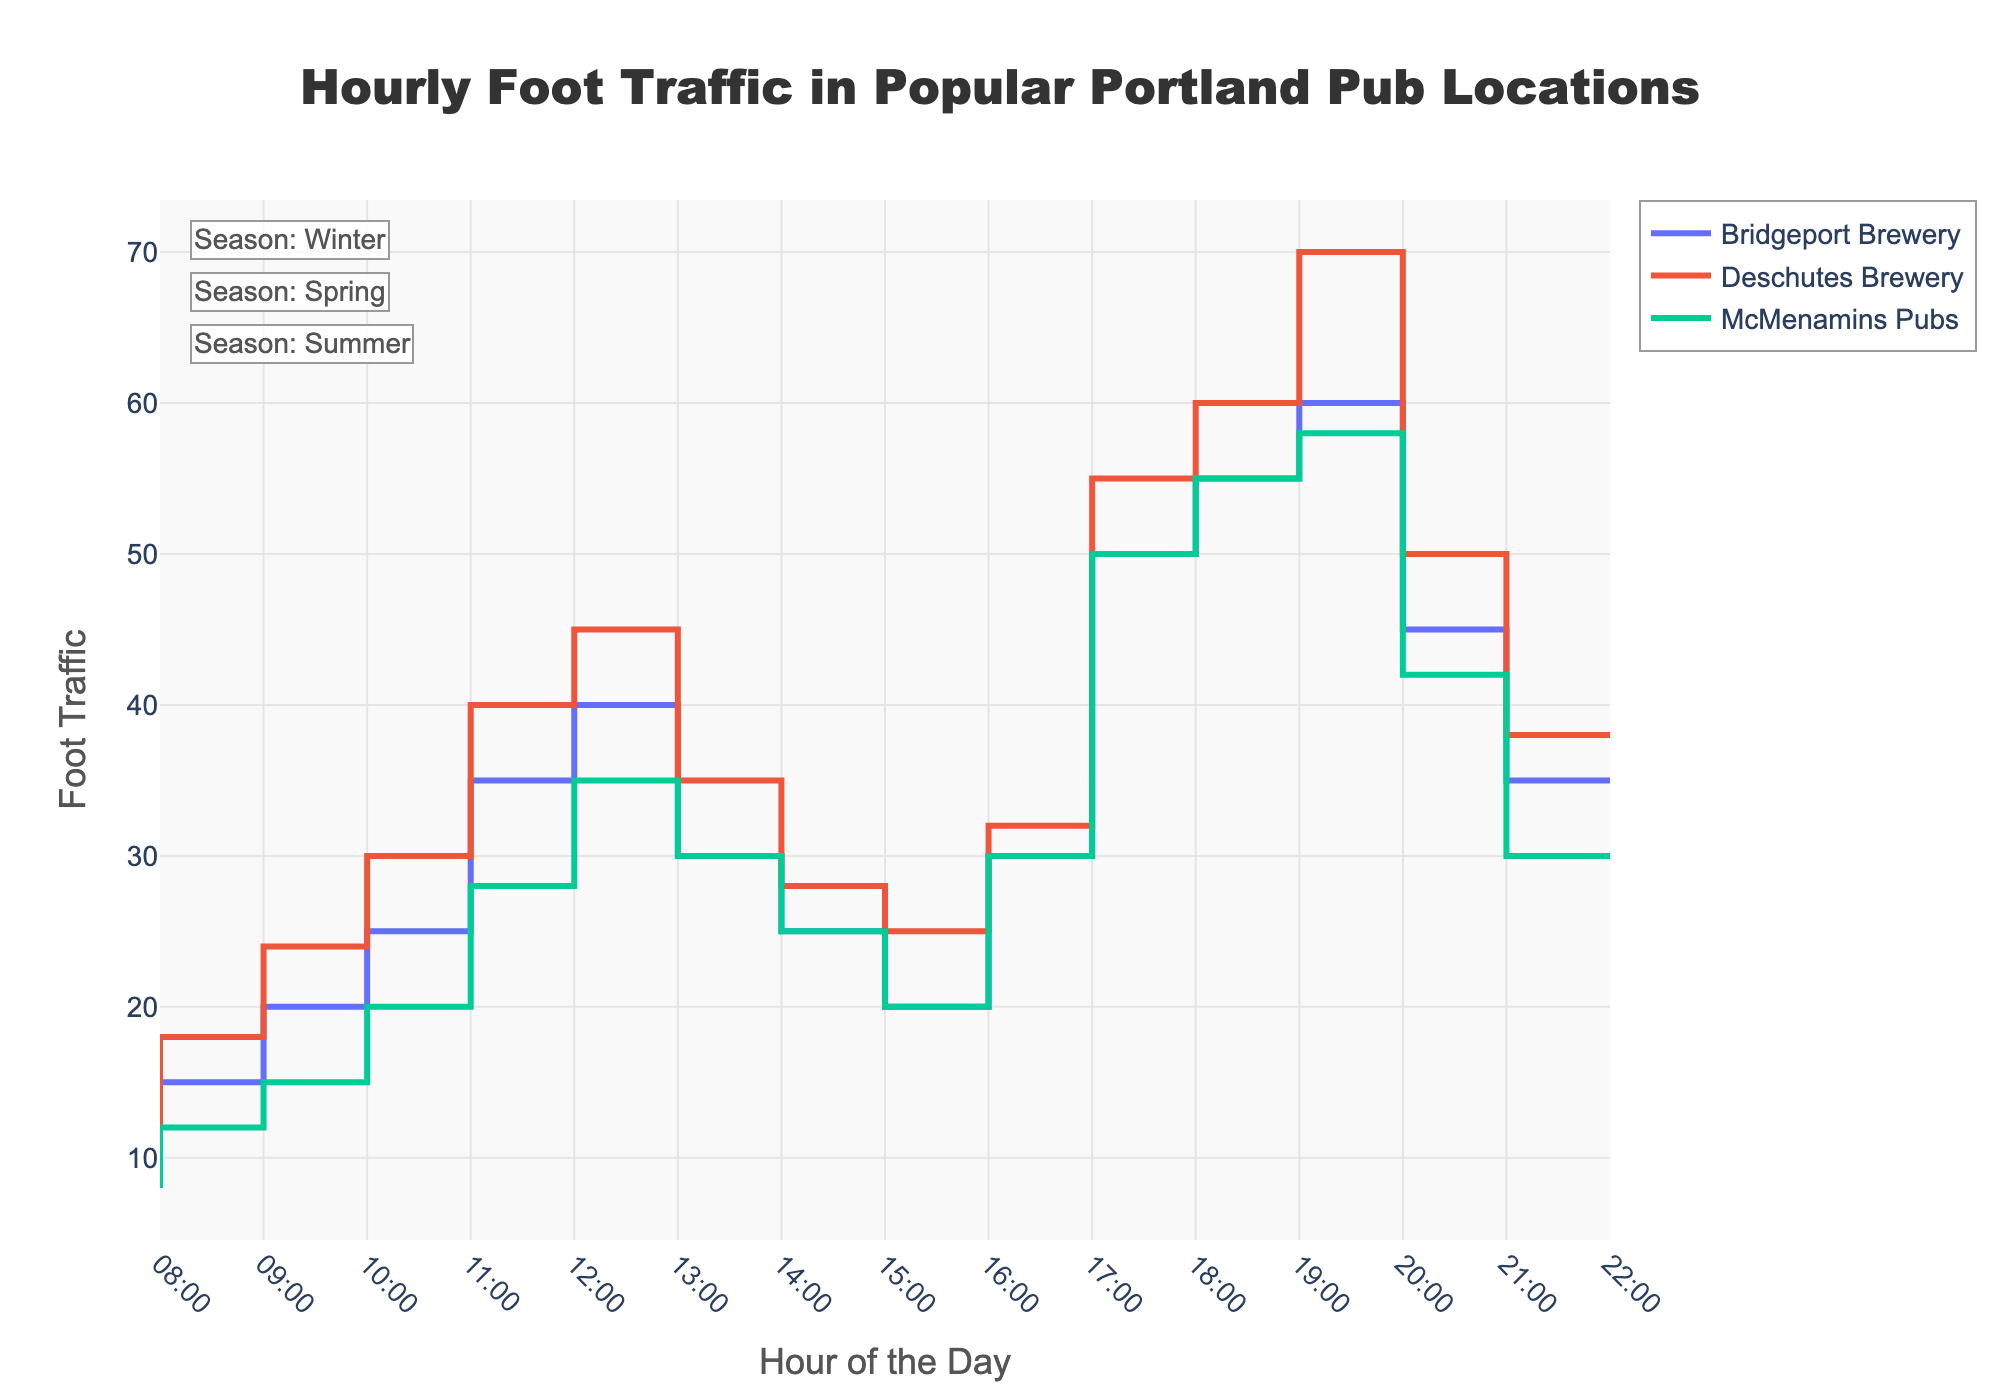What is the title of the plot? The title of the plot is generally located at the top center of the figure. It is a textual representation indicating the subject of the plot. The title reads, "Hourly Foot Traffic in Popular Portland Pub Locations".
Answer: Hourly Foot Traffic in Popular Portland Pub Locations How many popular Portland pub locations are shown in the plot? The plot visualizes data for multiple locations, each represented by a distinct line. Look at the legend or the plot lines to count the unique locations displayed.
Answer: Three Which location has the highest foot traffic at 8:00 PM (20:00)? To determine this, observe the y-axis values at 8:00 PM for all lines representing different locations. Compare the values to find the highest one.
Answer: Deschutes Brewery What is the foot traffic at McMenamins Pubs at 9:00 AM (09:00) during the summer? Locate the line representing McMenamins Pubs and look at where it intersects the 9:00 AM mark on the x-axis. The corresponding y-value indicates the foot traffic.
Answer: 12 Which location has the highest peak foot traffic and what is the value? Identify the maximum y-value for each location by observing the highest points of the lines. Compare these maximum values across all locations to find the highest one.
Answer: Deschutes Brewery, 70 What time does Bridgeport Brewery experience its highest foot traffic? Look along the line representing Bridgeport Brewery to find the y-axis peak value. Note the corresponding x-axis value, which represents the hour.
Answer: 8:00 PM Which locations have decreasing foot traffic after 9:00 PM (21:00)? Examine the lines for all locations and observe their slopes after 9:00 PM. Identify the lines that slope downward, indicating a decrease in foot traffic.
Answer: Bridgeport Brewery, Deschutes Brewery, McMenamins Pubs During which season does Deschutes Brewery data appear in the plot? Find the annotation box or legend related to Deschutes Brewery, which often includes seasonal information. Look for the label or color representing the season.
Answer: Spring What is the difference in foot traffic between Deschutes Brewery and McMenamins Pubs at 6:00 PM (18:00)? Locate both lines at 6:00 PM on the x-axis and note their y-axis values. Subtract the foot traffic of McMenamins Pubs from that of Deschutes Brewery.
Answer: 5 (55 - 50) Which location has a lower minimum foot traffic, and what is the value? Identify the lowest point in each line's y-values. Compare these minimum values across all locations to find the smallest one.
Answer: McMenamins Pubs, 8 